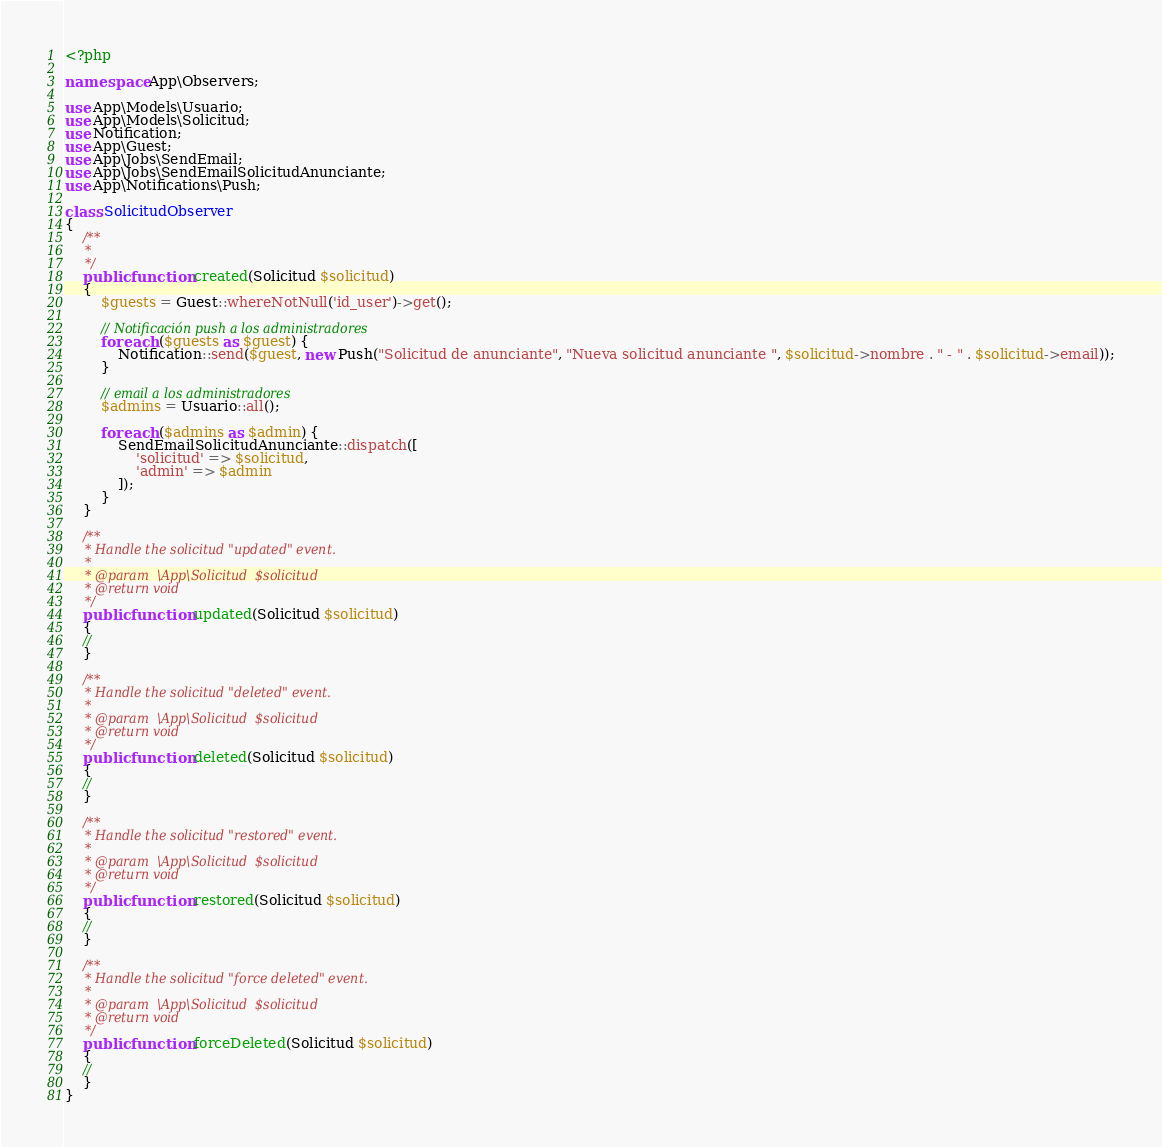<code> <loc_0><loc_0><loc_500><loc_500><_PHP_><?php

namespace App\Observers;

use App\Models\Usuario;
use App\Models\Solicitud;
use Notification;
use App\Guest;
use App\Jobs\SendEmail;
use App\Jobs\SendEmailSolicitudAnunciante;
use App\Notifications\Push;

class SolicitudObserver
{
    /**
     *
     */
    public function created(Solicitud $solicitud)
    {
        $guests = Guest::whereNotNull('id_user')->get();

        // Notificación push a los administradores
        foreach ($guests as $guest) {
            Notification::send($guest, new Push("Solicitud de anunciante", "Nueva solicitud anunciante ", $solicitud->nombre . " - " . $solicitud->email));
        }

        // email a los administradores
        $admins = Usuario::all();

        foreach ($admins as $admin) {
            SendEmailSolicitudAnunciante::dispatch([
                'solicitud' => $solicitud,
                'admin' => $admin
            ]);
        }
    }

    /**
     * Handle the solicitud "updated" event.
     *
     * @param  \App\Solicitud  $solicitud
     * @return void
     */
    public function updated(Solicitud $solicitud)
    {
    //
    }

    /**
     * Handle the solicitud "deleted" event.
     *
     * @param  \App\Solicitud  $solicitud
     * @return void
     */
    public function deleted(Solicitud $solicitud)
    {
    //
    }

    /**
     * Handle the solicitud "restored" event.
     *
     * @param  \App\Solicitud  $solicitud
     * @return void
     */
    public function restored(Solicitud $solicitud)
    {
    //
    }

    /**
     * Handle the solicitud "force deleted" event.
     *
     * @param  \App\Solicitud  $solicitud
     * @return void
     */
    public function forceDeleted(Solicitud $solicitud)
    {
    //
    }
}
</code> 